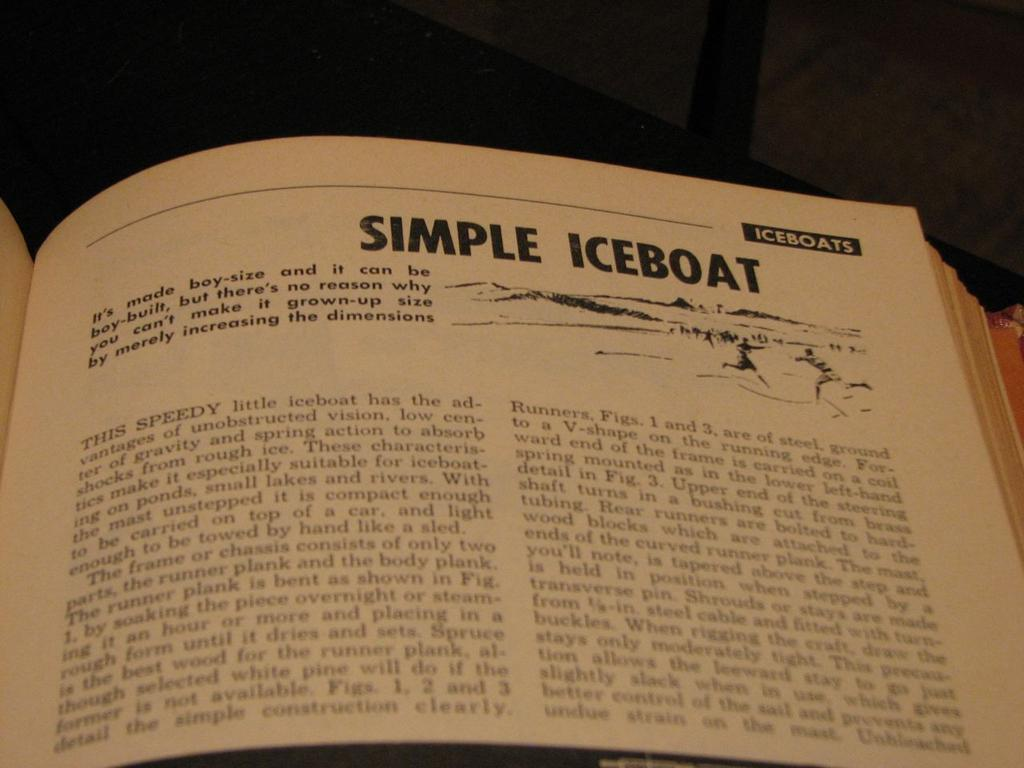<image>
Present a compact description of the photo's key features. A book is opened to a page on simple iceboats. 